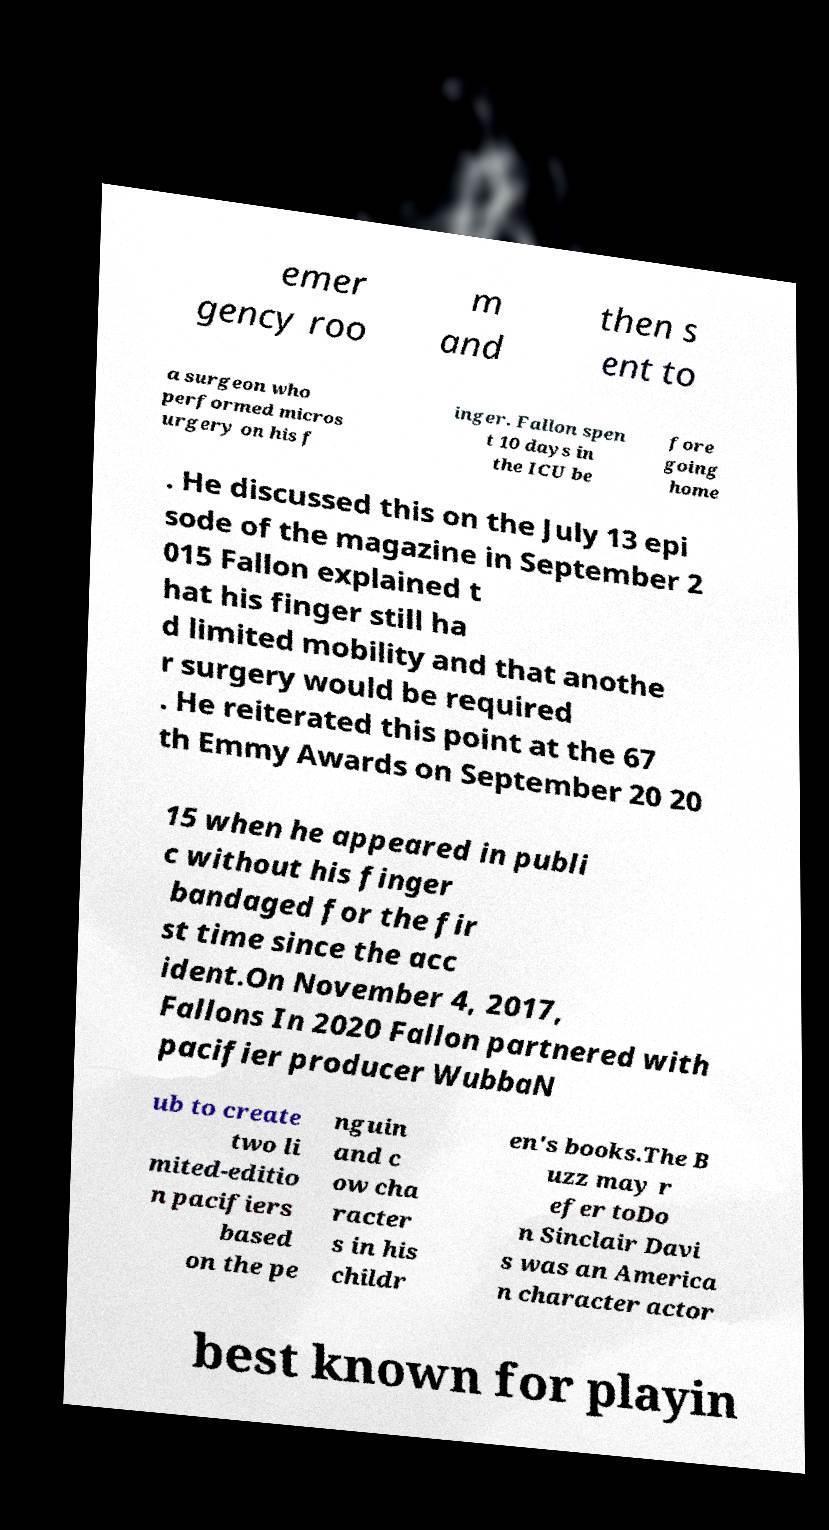I need the written content from this picture converted into text. Can you do that? emer gency roo m and then s ent to a surgeon who performed micros urgery on his f inger. Fallon spen t 10 days in the ICU be fore going home . He discussed this on the July 13 epi sode of the magazine in September 2 015 Fallon explained t hat his finger still ha d limited mobility and that anothe r surgery would be required . He reiterated this point at the 67 th Emmy Awards on September 20 20 15 when he appeared in publi c without his finger bandaged for the fir st time since the acc ident.On November 4, 2017, Fallons In 2020 Fallon partnered with pacifier producer WubbaN ub to create two li mited-editio n pacifiers based on the pe nguin and c ow cha racter s in his childr en's books.The B uzz may r efer toDo n Sinclair Davi s was an America n character actor best known for playin 